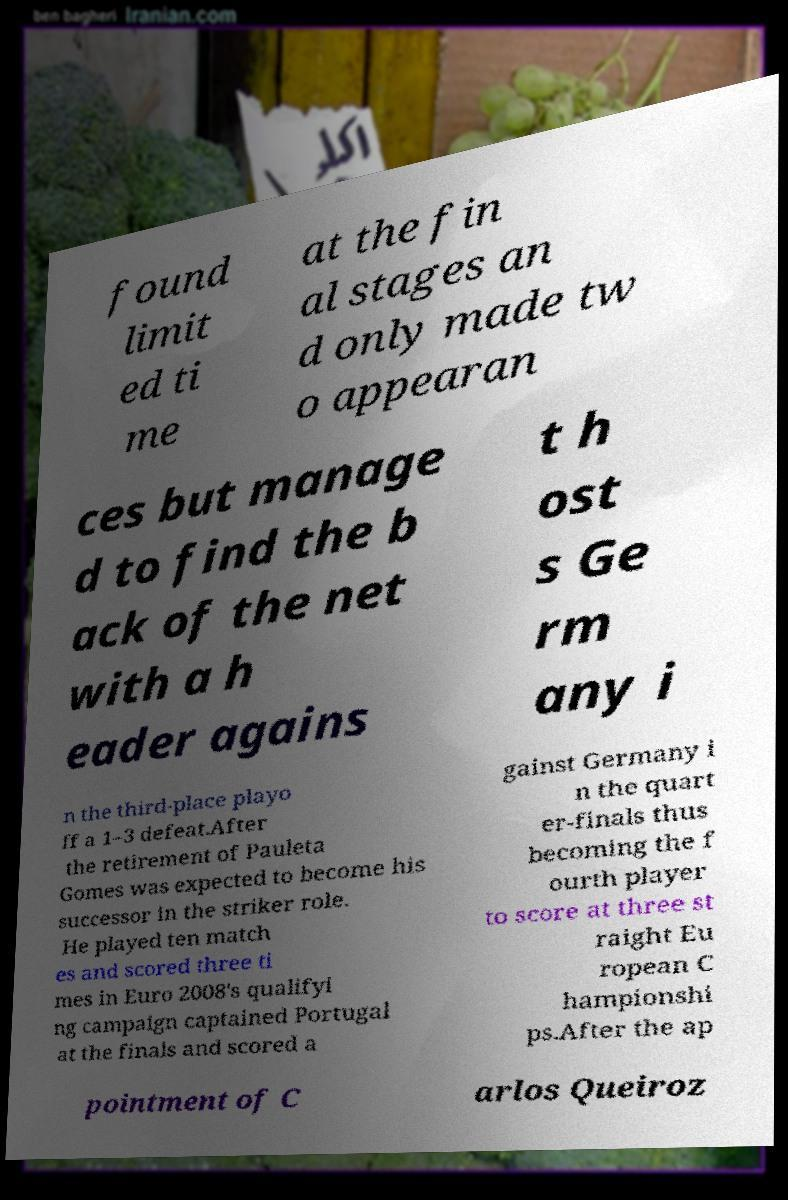Could you extract and type out the text from this image? found limit ed ti me at the fin al stages an d only made tw o appearan ces but manage d to find the b ack of the net with a h eader agains t h ost s Ge rm any i n the third-place playo ff a 1–3 defeat.After the retirement of Pauleta Gomes was expected to become his successor in the striker role. He played ten match es and scored three ti mes in Euro 2008's qualifyi ng campaign captained Portugal at the finals and scored a gainst Germany i n the quart er-finals thus becoming the f ourth player to score at three st raight Eu ropean C hampionshi ps.After the ap pointment of C arlos Queiroz 